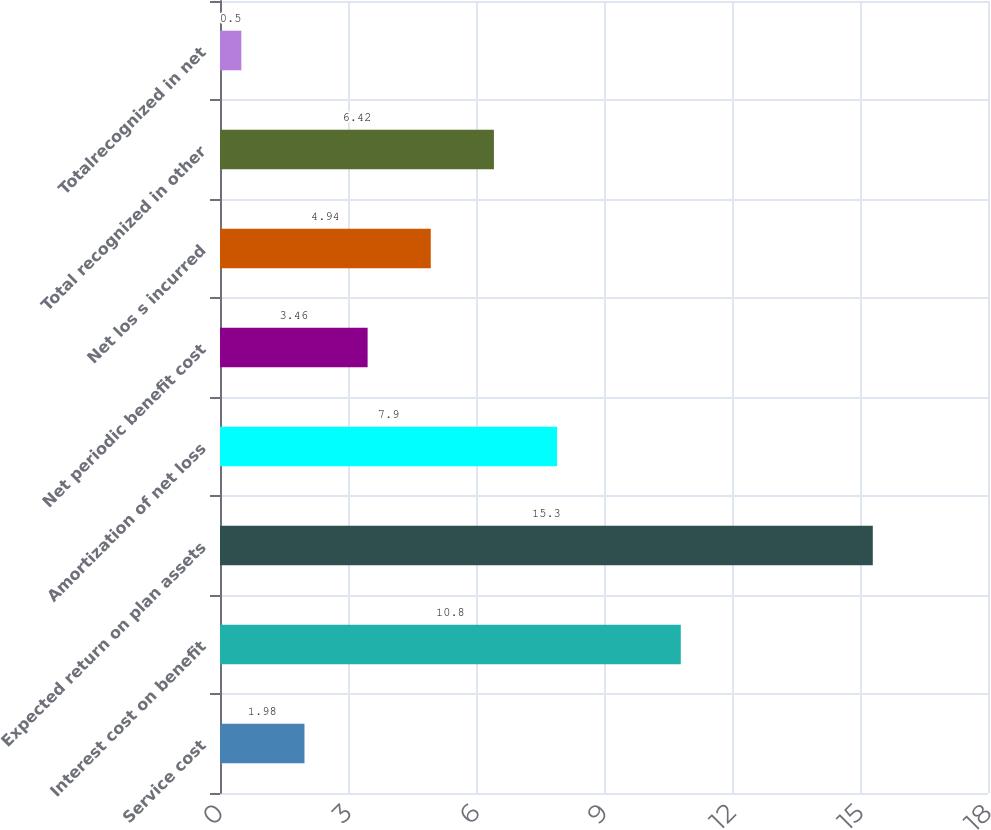Convert chart to OTSL. <chart><loc_0><loc_0><loc_500><loc_500><bar_chart><fcel>Service cost<fcel>Interest cost on benefit<fcel>Expected return on plan assets<fcel>Amortization of net loss<fcel>Net periodic benefit cost<fcel>Net los s incurred<fcel>Total recognized in other<fcel>Totalrecognized in net<nl><fcel>1.98<fcel>10.8<fcel>15.3<fcel>7.9<fcel>3.46<fcel>4.94<fcel>6.42<fcel>0.5<nl></chart> 